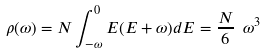Convert formula to latex. <formula><loc_0><loc_0><loc_500><loc_500>\rho ( \omega ) = N \int ^ { 0 } _ { - \omega } E ( E + \omega ) d E = \frac { N } { 6 } \ \omega ^ { 3 }</formula> 